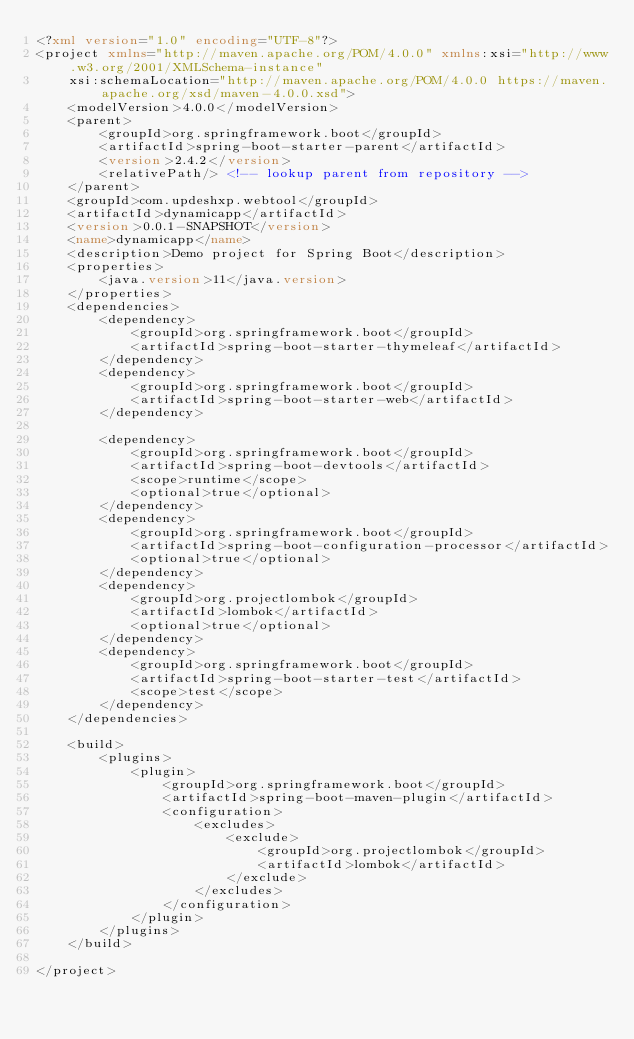Convert code to text. <code><loc_0><loc_0><loc_500><loc_500><_XML_><?xml version="1.0" encoding="UTF-8"?>
<project xmlns="http://maven.apache.org/POM/4.0.0" xmlns:xsi="http://www.w3.org/2001/XMLSchema-instance"
	xsi:schemaLocation="http://maven.apache.org/POM/4.0.0 https://maven.apache.org/xsd/maven-4.0.0.xsd">
	<modelVersion>4.0.0</modelVersion>
	<parent>
		<groupId>org.springframework.boot</groupId>
		<artifactId>spring-boot-starter-parent</artifactId>
		<version>2.4.2</version>
		<relativePath/> <!-- lookup parent from repository -->
	</parent>
	<groupId>com.updeshxp.webtool</groupId>
	<artifactId>dynamicapp</artifactId>
	<version>0.0.1-SNAPSHOT</version>
	<name>dynamicapp</name>
	<description>Demo project for Spring Boot</description>
	<properties>
		<java.version>11</java.version>
	</properties>
	<dependencies>
		<dependency>
			<groupId>org.springframework.boot</groupId>
			<artifactId>spring-boot-starter-thymeleaf</artifactId>
		</dependency>
		<dependency>
			<groupId>org.springframework.boot</groupId>
			<artifactId>spring-boot-starter-web</artifactId>
		</dependency>

		<dependency>
			<groupId>org.springframework.boot</groupId>
			<artifactId>spring-boot-devtools</artifactId>
			<scope>runtime</scope>
			<optional>true</optional>
		</dependency>
		<dependency>
			<groupId>org.springframework.boot</groupId>
			<artifactId>spring-boot-configuration-processor</artifactId>
			<optional>true</optional>
		</dependency>
		<dependency>
			<groupId>org.projectlombok</groupId>
			<artifactId>lombok</artifactId>
			<optional>true</optional>
		</dependency>
		<dependency>
			<groupId>org.springframework.boot</groupId>
			<artifactId>spring-boot-starter-test</artifactId>
			<scope>test</scope>
		</dependency>
	</dependencies>

	<build>
		<plugins>
			<plugin>
				<groupId>org.springframework.boot</groupId>
				<artifactId>spring-boot-maven-plugin</artifactId>
				<configuration>
					<excludes>
						<exclude>
							<groupId>org.projectlombok</groupId>
							<artifactId>lombok</artifactId>
						</exclude>
					</excludes>
				</configuration>
			</plugin>
		</plugins>
	</build>

</project>
</code> 